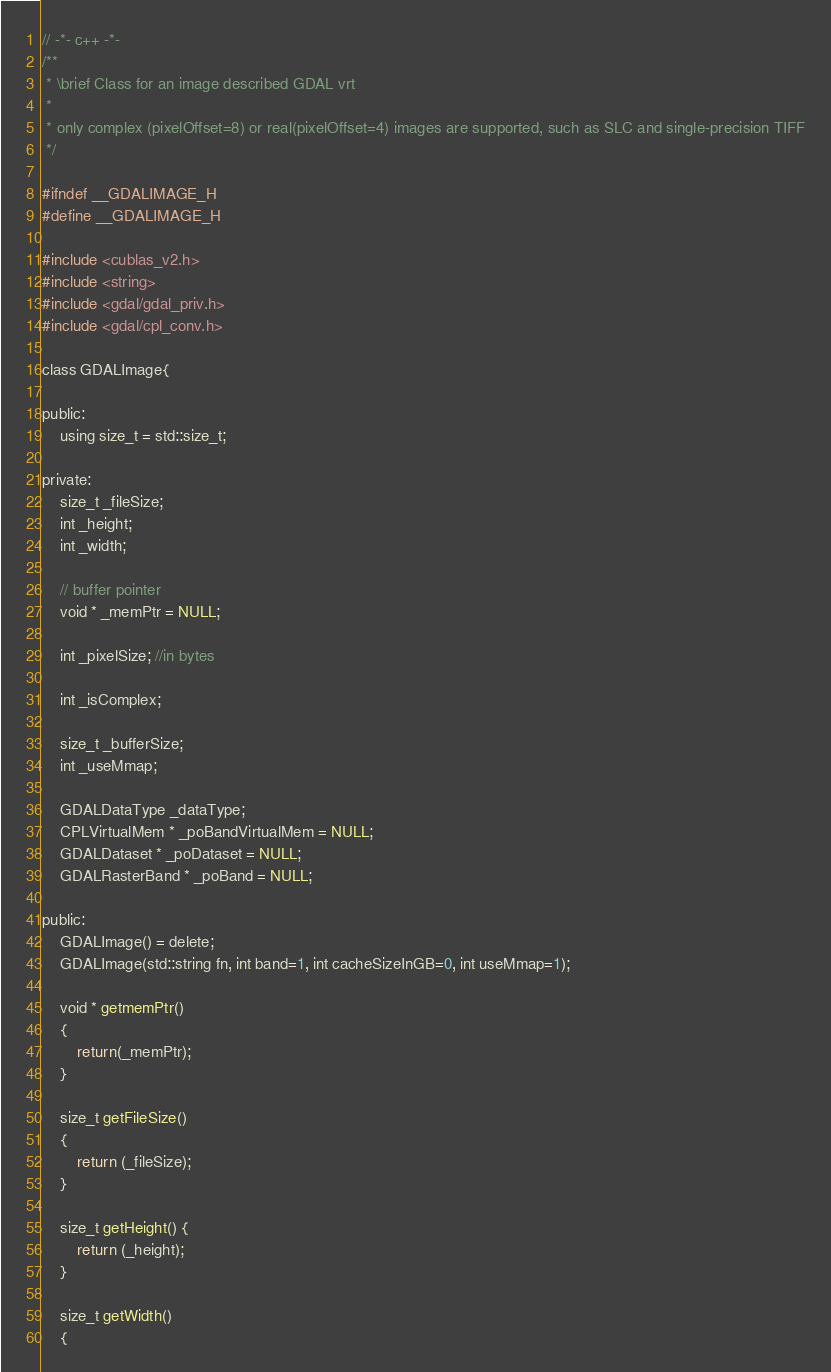Convert code to text. <code><loc_0><loc_0><loc_500><loc_500><_C_>// -*- c++ -*-
/**
 * \brief Class for an image described GDAL vrt
 *
 * only complex (pixelOffset=8) or real(pixelOffset=4) images are supported, such as SLC and single-precision TIFF
 */

#ifndef __GDALIMAGE_H
#define __GDALIMAGE_H

#include <cublas_v2.h>
#include <string>
#include <gdal/gdal_priv.h>
#include <gdal/cpl_conv.h>

class GDALImage{

public:
    using size_t = std::size_t;

private:
    size_t _fileSize;
    int _height;
    int _width;

    // buffer pointer
    void * _memPtr = NULL;

    int _pixelSize; //in bytes

    int _isComplex;

    size_t _bufferSize;
    int _useMmap;

    GDALDataType _dataType;
    CPLVirtualMem * _poBandVirtualMem = NULL;
    GDALDataset * _poDataset = NULL;
    GDALRasterBand * _poBand = NULL;

public:
    GDALImage() = delete;
    GDALImage(std::string fn, int band=1, int cacheSizeInGB=0, int useMmap=1);

    void * getmemPtr()
    {
        return(_memPtr);
    }

    size_t getFileSize()
    {
        return (_fileSize);
    }

    size_t getHeight() {
        return (_height);
    }

    size_t getWidth()
    {</code> 